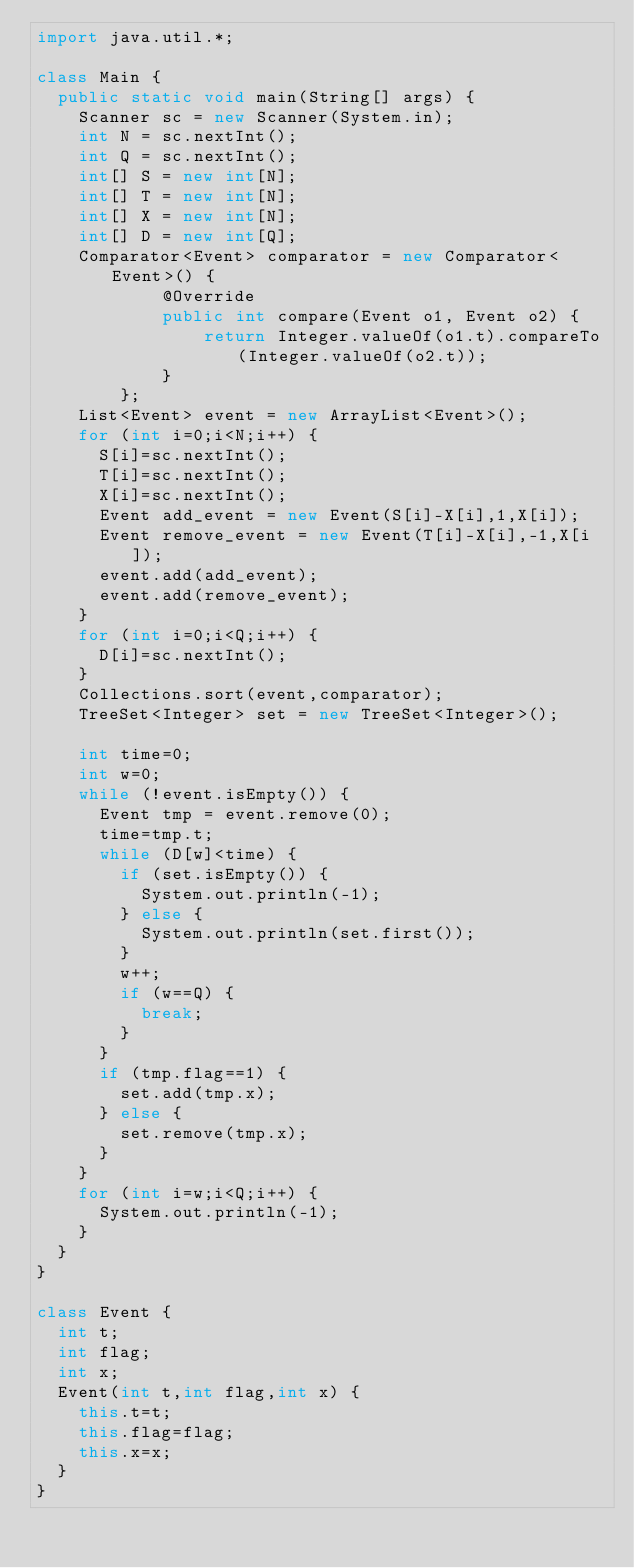Convert code to text. <code><loc_0><loc_0><loc_500><loc_500><_Java_>import java.util.*;

class Main {
	public static void main(String[] args) {
		Scanner sc = new Scanner(System.in);
		int N = sc.nextInt();
		int Q = sc.nextInt();
		int[] S = new int[N];
		int[] T = new int[N];
		int[] X = new int[N];
		int[] D = new int[Q];
		Comparator<Event> comparator = new Comparator<Event>() {
            @Override
            public int compare(Event o1, Event o2) {
                return Integer.valueOf(o1.t).compareTo(Integer.valueOf(o2.t));
            }
        };
		List<Event> event = new ArrayList<Event>();
		for (int i=0;i<N;i++) {
			S[i]=sc.nextInt();
			T[i]=sc.nextInt();
			X[i]=sc.nextInt();
			Event add_event = new Event(S[i]-X[i],1,X[i]);
			Event remove_event = new Event(T[i]-X[i],-1,X[i]);
			event.add(add_event);
			event.add(remove_event);
		}
		for (int i=0;i<Q;i++) {
			D[i]=sc.nextInt();
		}
		Collections.sort(event,comparator);
		TreeSet<Integer> set = new TreeSet<Integer>();

		int time=0;
		int w=0;
		while (!event.isEmpty()) {
			Event tmp = event.remove(0);
			time=tmp.t;
			while (D[w]<time) {
				if (set.isEmpty()) {
					System.out.println(-1);
				} else {
					System.out.println(set.first());
				}
				w++;
				if (w==Q) {
					break;
				}
			}
			if (tmp.flag==1) {
				set.add(tmp.x);
			} else {
				set.remove(tmp.x);
			}
		}
		for (int i=w;i<Q;i++) {
			System.out.println(-1);
		}
	}
}

class Event {
	int t;
	int flag;
	int x;
	Event(int t,int flag,int x) {
		this.t=t;
		this.flag=flag;
		this.x=x;
	}
}</code> 